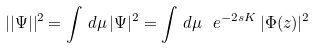<formula> <loc_0><loc_0><loc_500><loc_500>| | \Psi | | ^ { 2 } = \int \, d \mu \, | \Psi | ^ { 2 } = \int \, d \mu \ e ^ { - 2 s K } \, | \Phi ( z ) | ^ { 2 }</formula> 